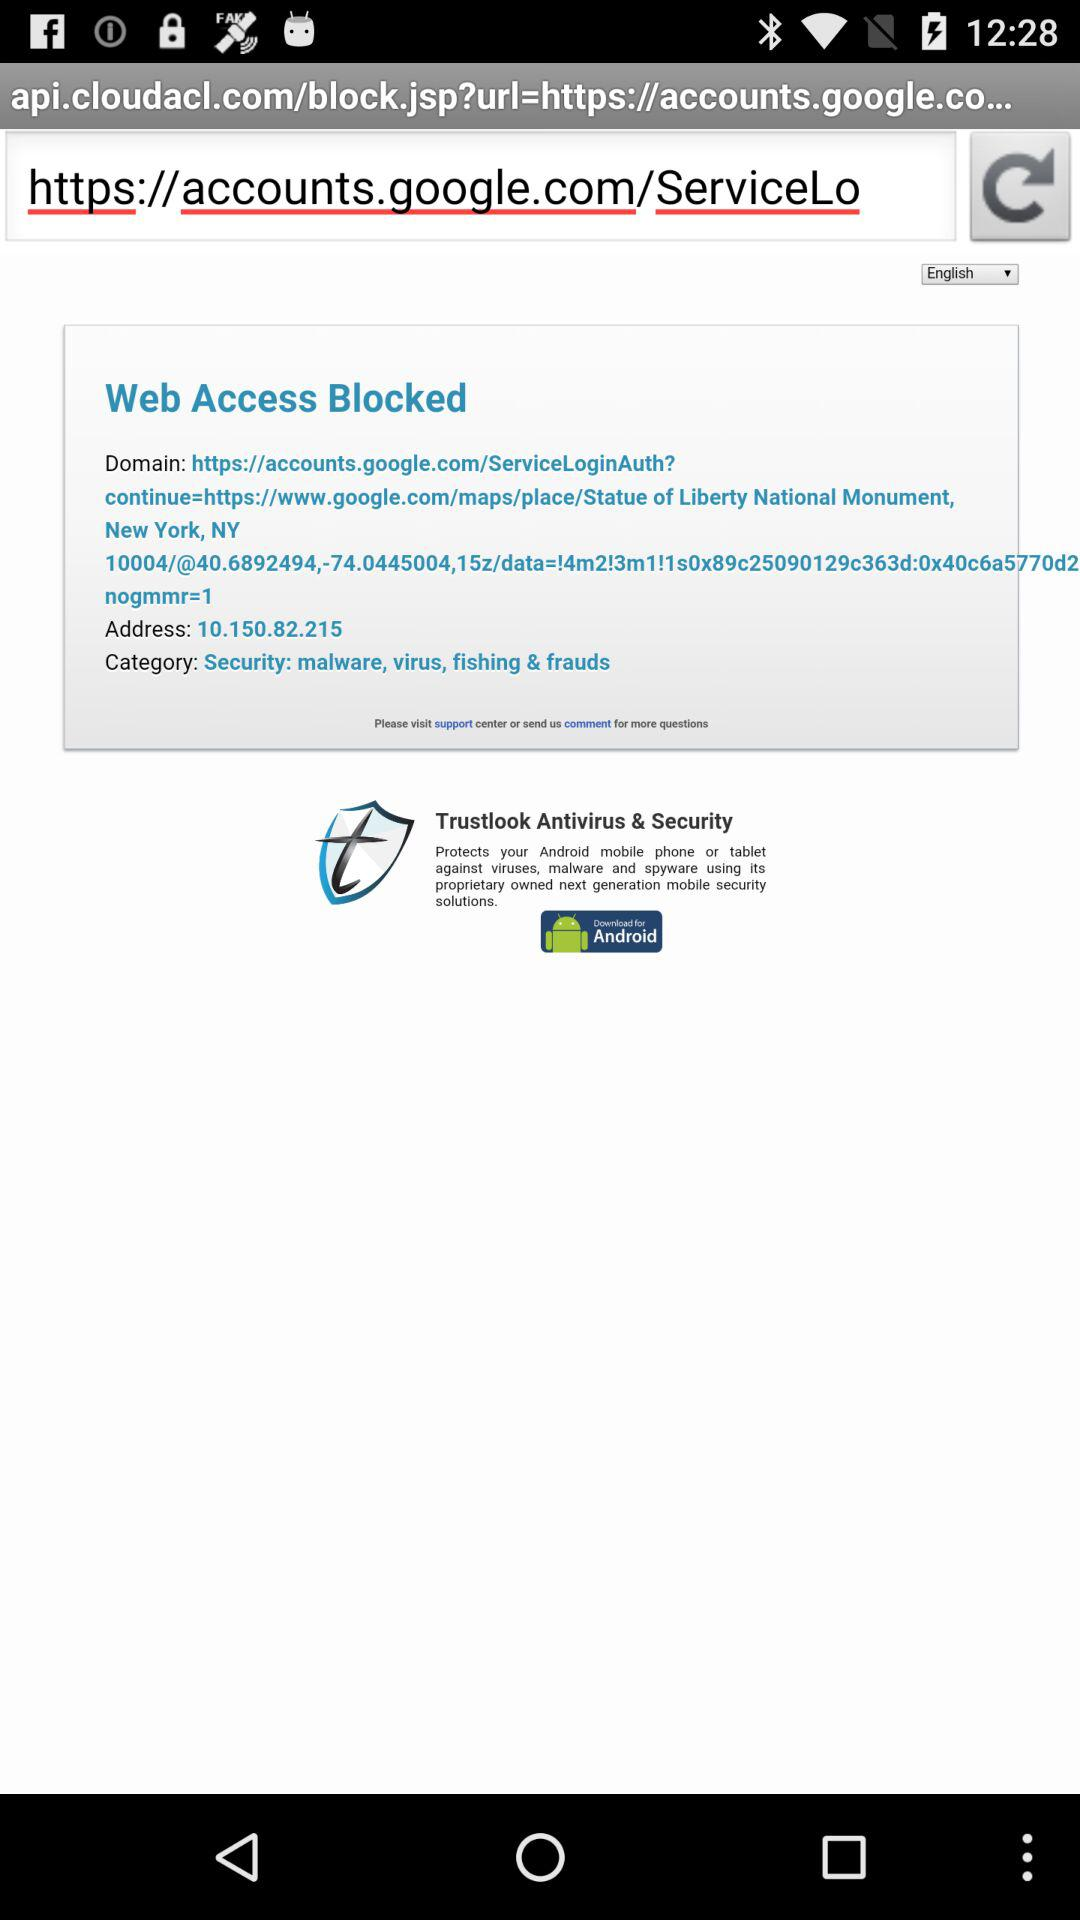What is the URL? The URL is "https://accounts.google.com/ServiceLoginAuth?". 